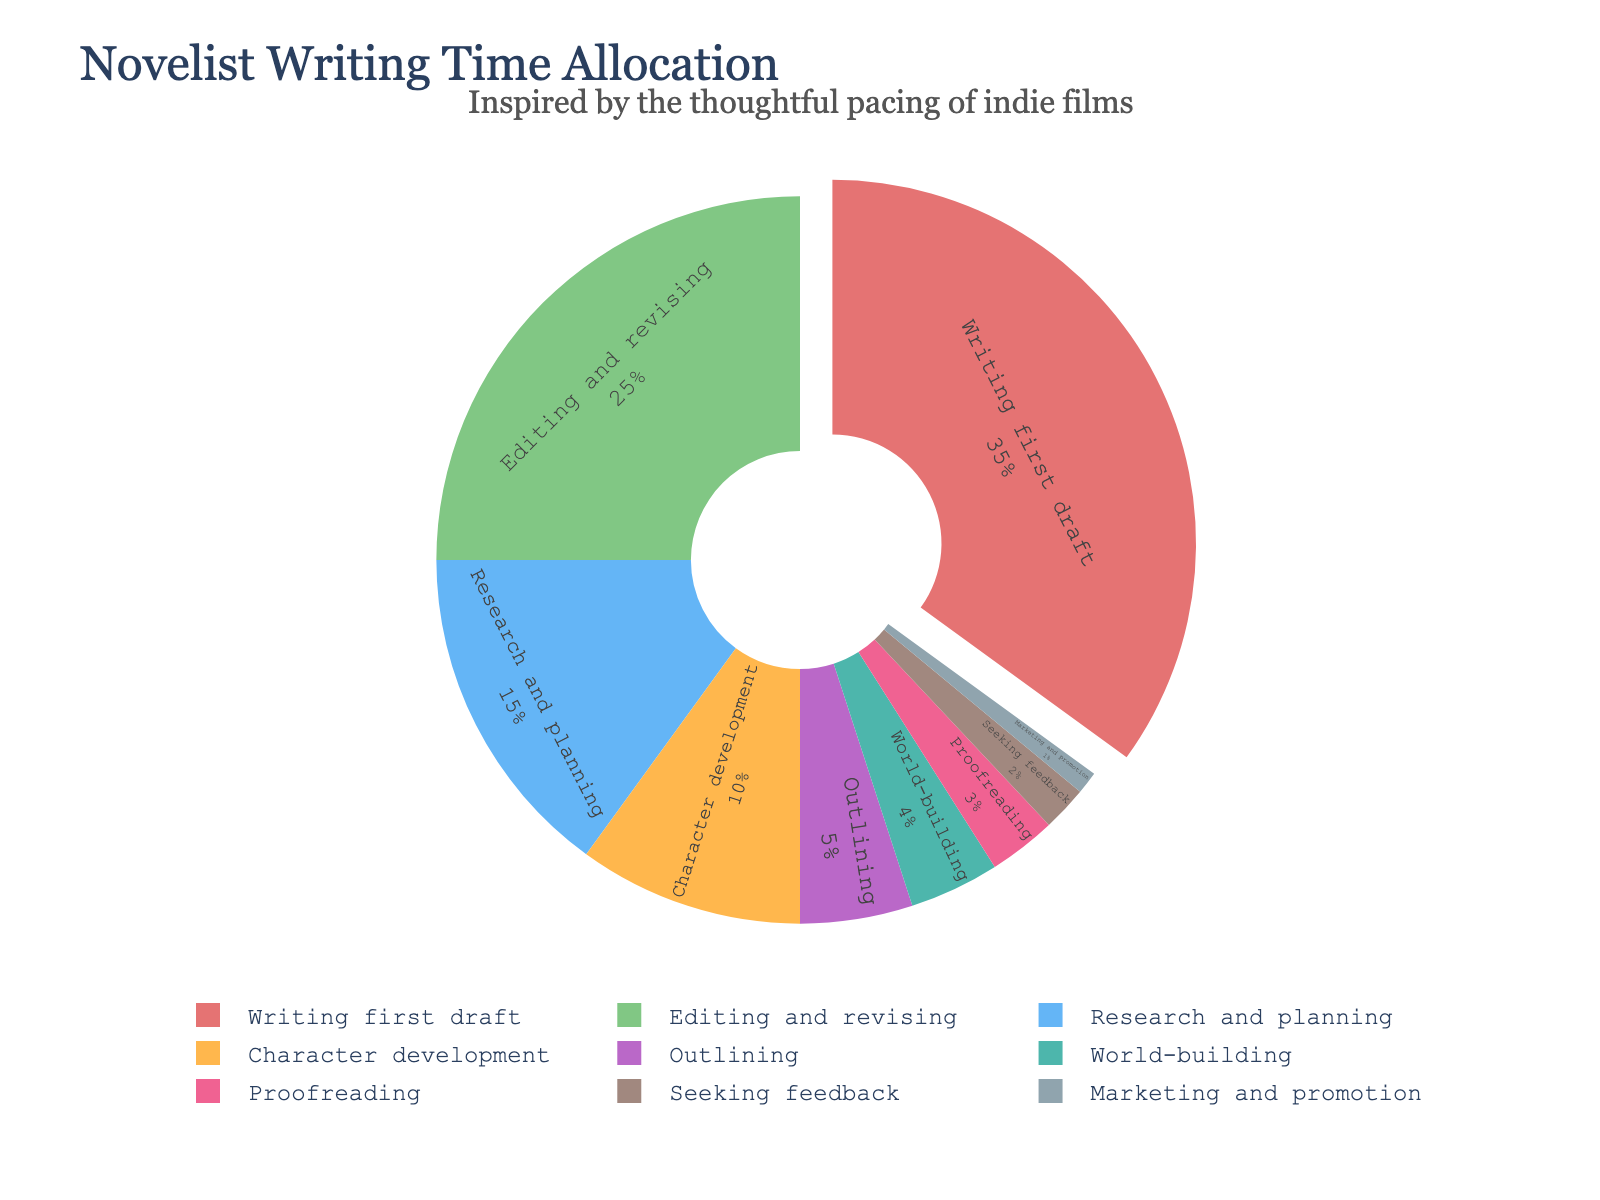What activity takes up the largest percentage of a novelist's writing time? Look at the segment with the greatest portion of the pie chart. The largest slice is "Writing first draft" at 35%.
Answer: Writing first draft Which two activities together make up the same percentage as "Editing and revising"? "Research and planning" (15%) + "Character development" (10%) = 25%, which is equal to "Editing and revising" (25%).
Answer: Research and planning and Character development What is the total percentage dedicated to "Outlining", "World-building", and "Proofreading"? By adding the percentages for "Outlining" (5%), "World-building" (4%), and "Proofreading" (3%), the total is 5 + 4 + 3 = 12%.
Answer: 12% How does the time spent on "Seeking feedback" compare to "Marketing and promotion"? "Seeking feedback" is 2% while "Marketing and promotion" is 1%. Hence, "Seeking feedback" is twice as much as "Marketing and promotion".
Answer: Seeking feedback is greater Which activity is represented in green in the pie chart? Locate the segment with the green color. The pie chart indicates that "Editing and revising" is green and accounts for 25%.
Answer: Editing and revising What is the difference in percentage between "Writing first draft" and "Marketing and promotion"? Subtract "Marketing and promotion" (1%) from "Writing first draft" (35%), which results in 35 - 1 = 34%.
Answer: 34% Is the percentage of time spent on "World-building" greater or less than the percentage spent on "Character development"? "World-building" is 4% and "Character development" is 10%. Therefore, "World-building" is less than "Character development".
Answer: Less What percentage of time is allocated to all activities not directly related to drafting (Writing first draft) and revising (Editing and revising)? Add the percentages for all activities except "Writing first draft" (35%) and "Editing and revising" (25%): 15 + 10 + 5 + 4 + 3 + 2 + 1 = 40%.
Answer: 40% Which activities are highlighted and what visual attribute indicates their importance? The segment for "Writing first draft" is slightly pulled out from the pie chart, indicating significance.
Answer: Writing first draft 